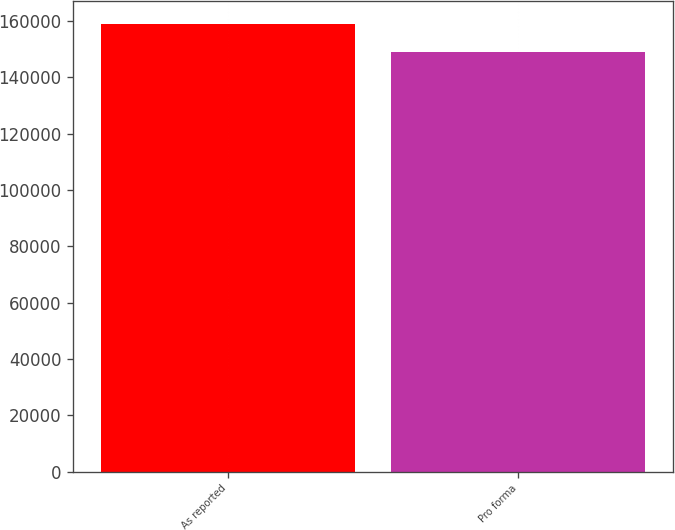Convert chart to OTSL. <chart><loc_0><loc_0><loc_500><loc_500><bar_chart><fcel>As reported<fcel>Pro forma<nl><fcel>159068<fcel>148897<nl></chart> 